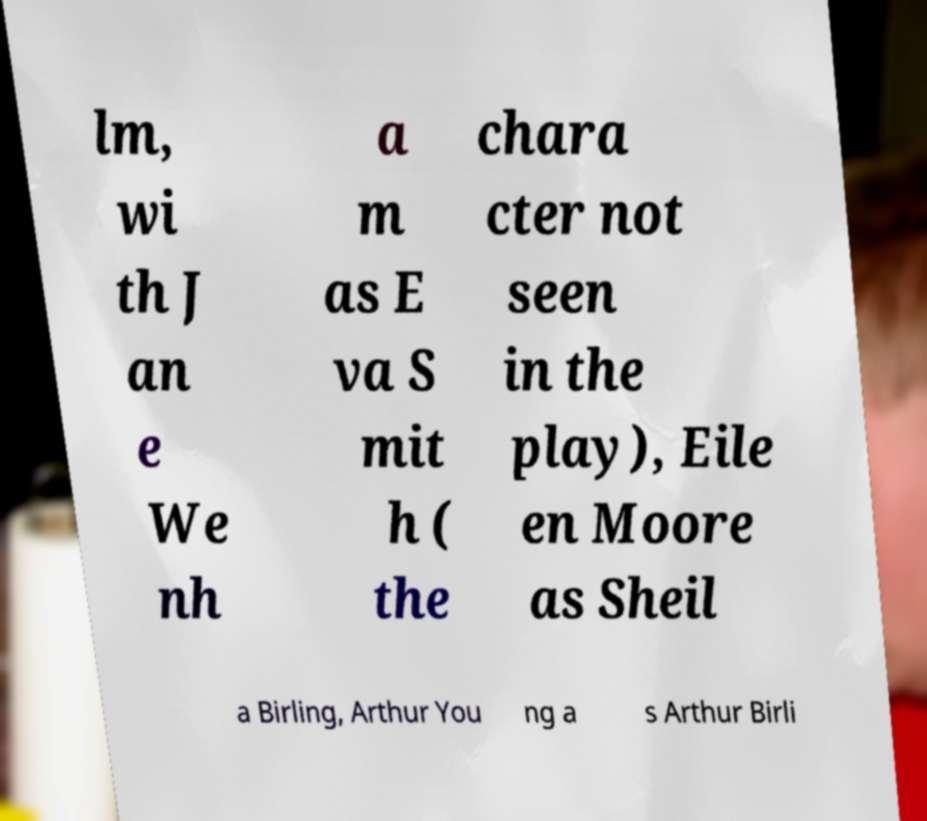There's text embedded in this image that I need extracted. Can you transcribe it verbatim? lm, wi th J an e We nh a m as E va S mit h ( the chara cter not seen in the play), Eile en Moore as Sheil a Birling, Arthur You ng a s Arthur Birli 